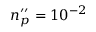<formula> <loc_0><loc_0><loc_500><loc_500>n _ { p } ^ { \prime \prime } = 1 0 ^ { - 2 }</formula> 